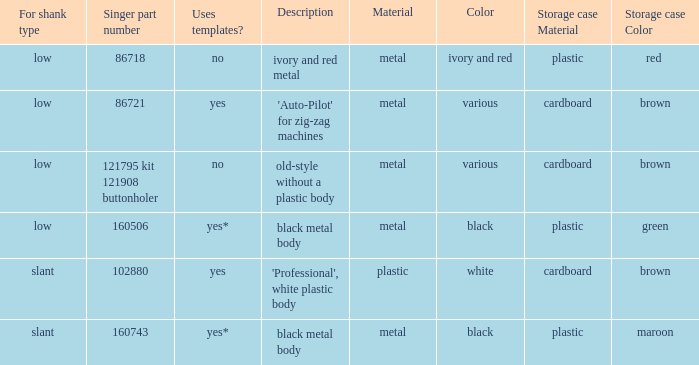What is the shank type of the buttonholer that comes with a red plastic storage case? Low. 